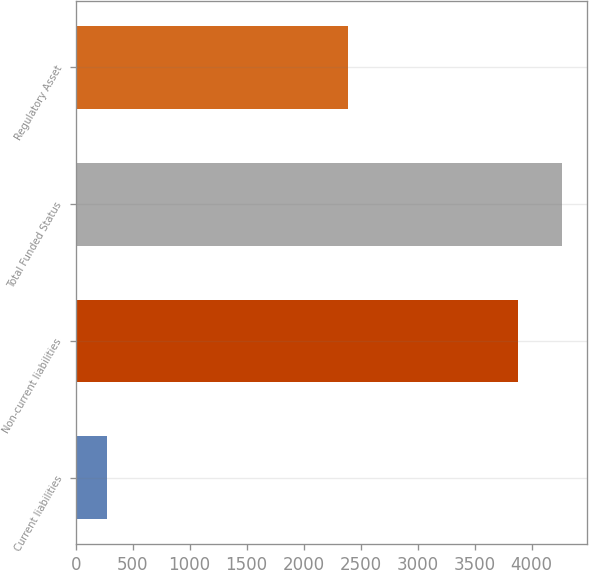<chart> <loc_0><loc_0><loc_500><loc_500><bar_chart><fcel>Current liabilities<fcel>Non-current liabilities<fcel>Total Funded Status<fcel>Regulatory Asset<nl><fcel>272<fcel>3881<fcel>4269.1<fcel>2385<nl></chart> 